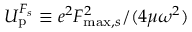<formula> <loc_0><loc_0><loc_500><loc_500>U _ { p } ^ { F _ { s } } \equiv e ^ { 2 } F _ { \max , s } ^ { 2 } / { ( 4 \mu \omega ^ { 2 } ) }</formula> 